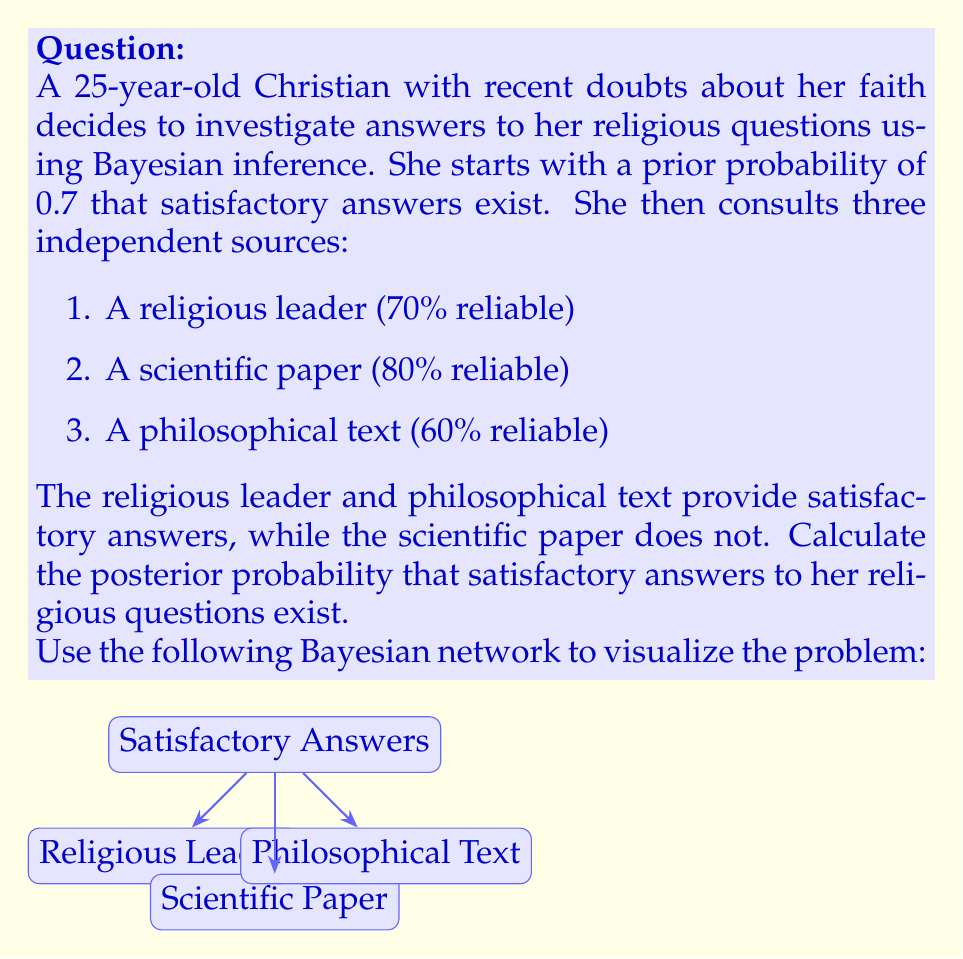Help me with this question. Let's approach this problem step-by-step using Bayes' theorem:

1) Let A be the event that satisfactory answers exist.
   Let B, C, and D be the events of getting positive responses from the religious leader, scientific paper, and philosophical text, respectively.

2) We're given:
   P(A) = 0.7 (prior probability)
   P(B|A) = 0.7, P(C|A) = 0.8, P(D|A) = 0.6 (reliabilities when A is true)
   P(B|not A) = 0.3, P(C|not A) = 0.2, P(D|not A) = 0.4 (reliabilities when A is false)

3) We observed B, not C, and D. We need to calculate P(A|B,not C,D).

4) Using Bayes' theorem:

   $$P(A|B,\text{not }C,D) = \frac{P(B,\text{not }C,D|A) \cdot P(A)}{P(B,\text{not }C,D)}$$

5) Calculate P(B,not C,D|A):
   $$P(B,\text{not }C,D|A) = P(B|A) \cdot P(\text{not }C|A) \cdot P(D|A) = 0.7 \cdot (1-0.8) \cdot 0.6 = 0.084$$

6) Calculate P(B,not C,D|not A):
   $$P(B,\text{not }C,D|\text{not }A) = P(B|\text{not }A) \cdot P(\text{not }C|\text{not }A) \cdot P(D|\text{not }A) = 0.3 \cdot 0.8 \cdot 0.4 = 0.096$$

7) Calculate P(B,not C,D):
   $$P(B,\text{not }C,D) = P(B,\text{not }C,D|A) \cdot P(A) + P(B,\text{not }C,D|\text{not }A) \cdot P(\text{not }A)$$
   $$= 0.084 \cdot 0.7 + 0.096 \cdot 0.3 = 0.0588 + 0.0288 = 0.0876$$

8) Now we can calculate the posterior probability:
   $$P(A|B,\text{not }C,D) = \frac{0.084 \cdot 0.7}{0.0876} \approx 0.6712$$

Therefore, the posterior probability that satisfactory answers exist is approximately 0.6712 or 67.12%.
Answer: 0.6712 